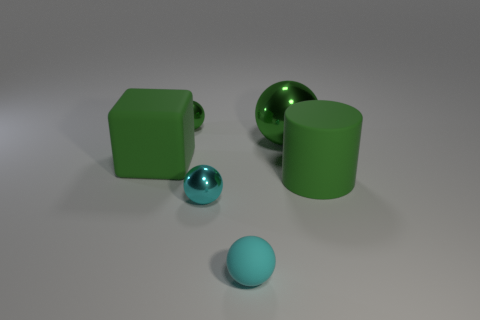Subtract all big balls. How many balls are left? 3 Add 4 big green objects. How many objects exist? 10 Subtract all purple cylinders. How many green spheres are left? 2 Subtract all brown spheres. Subtract all green blocks. How many spheres are left? 4 Subtract all balls. How many objects are left? 2 Subtract all large green balls. Subtract all green rubber blocks. How many objects are left? 4 Add 3 green rubber blocks. How many green rubber blocks are left? 4 Add 4 cyan balls. How many cyan balls exist? 6 Subtract 0 blue cylinders. How many objects are left? 6 